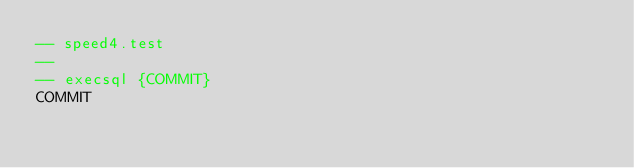Convert code to text. <code><loc_0><loc_0><loc_500><loc_500><_SQL_>-- speed4.test
-- 
-- execsql {COMMIT}
COMMIT</code> 